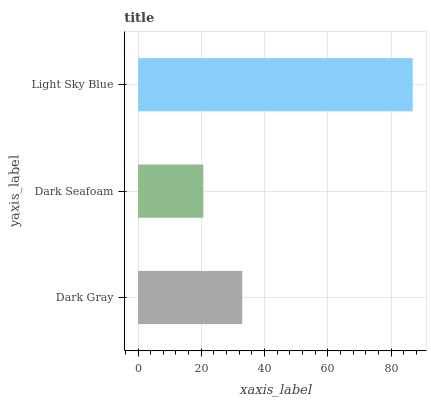Is Dark Seafoam the minimum?
Answer yes or no. Yes. Is Light Sky Blue the maximum?
Answer yes or no. Yes. Is Light Sky Blue the minimum?
Answer yes or no. No. Is Dark Seafoam the maximum?
Answer yes or no. No. Is Light Sky Blue greater than Dark Seafoam?
Answer yes or no. Yes. Is Dark Seafoam less than Light Sky Blue?
Answer yes or no. Yes. Is Dark Seafoam greater than Light Sky Blue?
Answer yes or no. No. Is Light Sky Blue less than Dark Seafoam?
Answer yes or no. No. Is Dark Gray the high median?
Answer yes or no. Yes. Is Dark Gray the low median?
Answer yes or no. Yes. Is Dark Seafoam the high median?
Answer yes or no. No. Is Dark Seafoam the low median?
Answer yes or no. No. 